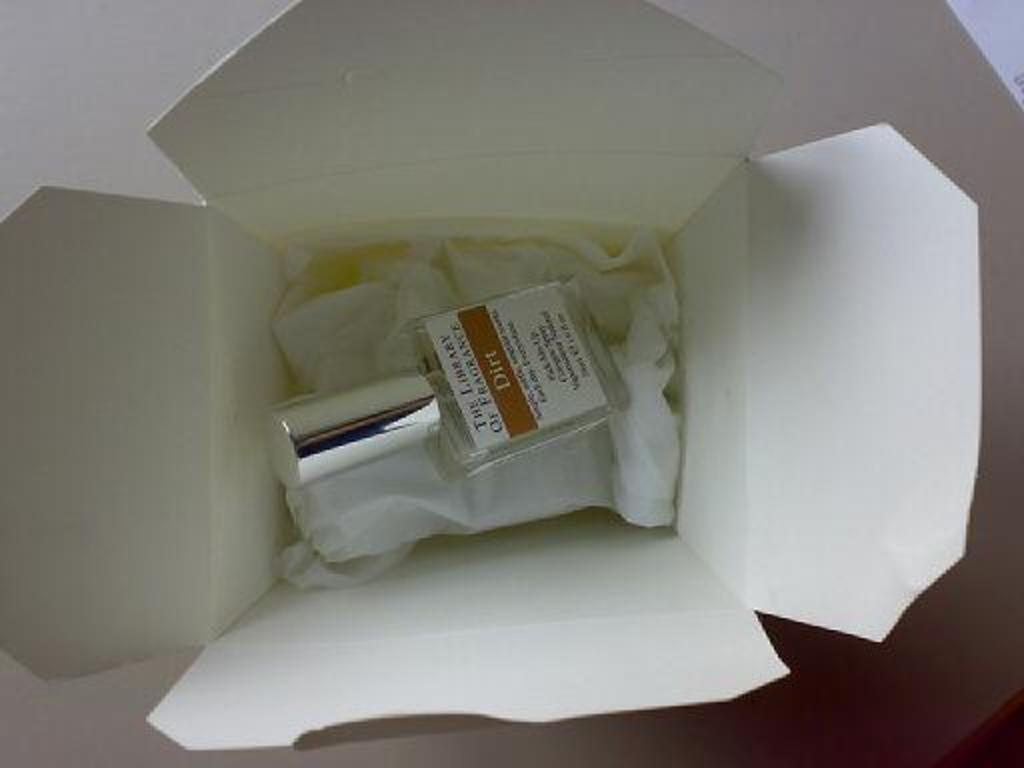<image>
Share a concise interpretation of the image provided. A small bottle in a white box that has The Library of France on the bottle's label. 